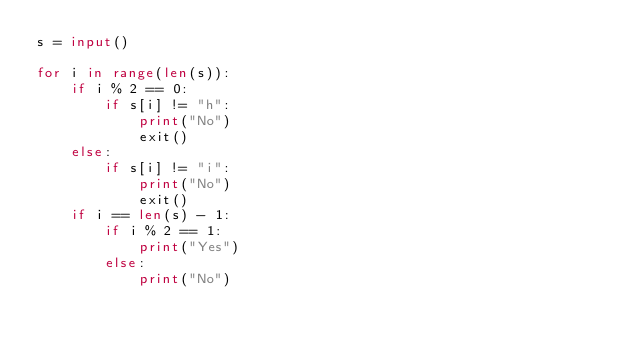<code> <loc_0><loc_0><loc_500><loc_500><_Python_>s = input()

for i in range(len(s)):
    if i % 2 == 0:
        if s[i] != "h":
            print("No")
            exit()
    else:
        if s[i] != "i":
            print("No")
            exit()
    if i == len(s) - 1:
        if i % 2 == 1:
            print("Yes")
        else:
            print("No")</code> 